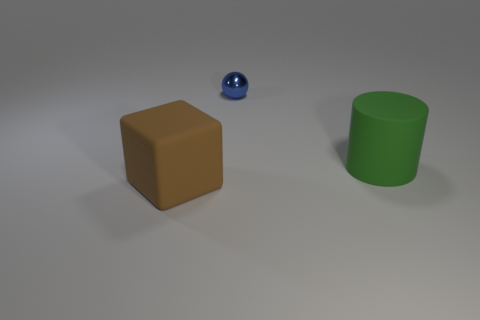What is the size of the matte thing that is behind the rubber object that is left of the green thing?
Offer a very short reply. Large. Are there an equal number of shiny balls in front of the large matte cylinder and green rubber things that are in front of the big brown rubber block?
Your answer should be compact. Yes. How many big rubber things have the same color as the metal thing?
Offer a very short reply. 0. What is the shape of the matte object to the left of the big rubber object that is behind the big thing in front of the cylinder?
Your answer should be compact. Cube. How big is the brown thing?
Ensure brevity in your answer.  Large. What color is the other big thing that is made of the same material as the brown object?
Give a very brief answer. Green. How many green objects are made of the same material as the sphere?
Your answer should be very brief. 0. The matte object on the left side of the rubber object that is behind the large block is what color?
Offer a terse response. Brown. What is the color of the matte object that is the same size as the rubber cylinder?
Give a very brief answer. Brown. Is there another large object of the same shape as the large green matte object?
Your answer should be very brief. No. 